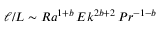<formula> <loc_0><loc_0><loc_500><loc_500>\ell / L \sim R a ^ { 1 + b } \, E k ^ { 2 b + 2 } \, P r ^ { - 1 - b }</formula> 